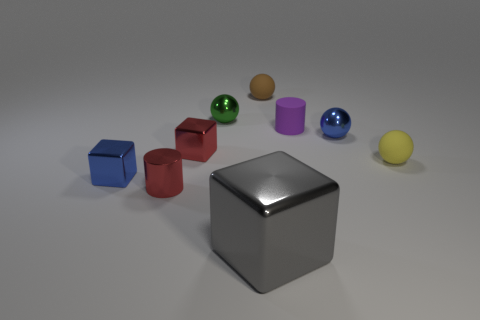Subtract all green shiny balls. How many balls are left? 3 Add 1 green metallic spheres. How many objects exist? 10 Subtract all blocks. How many objects are left? 6 Subtract all green balls. How many balls are left? 3 Subtract 1 red cylinders. How many objects are left? 8 Subtract 1 cylinders. How many cylinders are left? 1 Subtract all purple cylinders. Subtract all blue balls. How many cylinders are left? 1 Subtract all purple cylinders. How many cyan blocks are left? 0 Subtract all big blue objects. Subtract all large blocks. How many objects are left? 8 Add 6 big gray metal blocks. How many big gray metal blocks are left? 7 